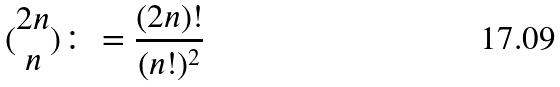<formula> <loc_0><loc_0><loc_500><loc_500>( \begin{matrix} 2 n \\ n \end{matrix} ) \colon = \frac { ( 2 n ) ! } { ( n ! ) ^ { 2 } }</formula> 